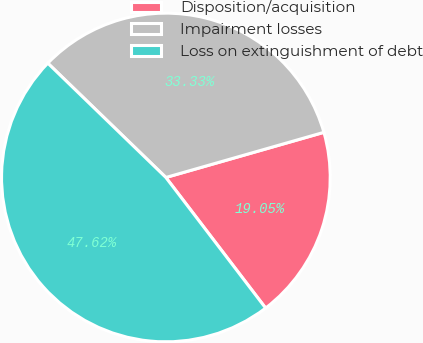Convert chart to OTSL. <chart><loc_0><loc_0><loc_500><loc_500><pie_chart><fcel>Disposition/acquisition<fcel>Impairment losses<fcel>Loss on extinguishment of debt<nl><fcel>19.05%<fcel>33.33%<fcel>47.62%<nl></chart> 